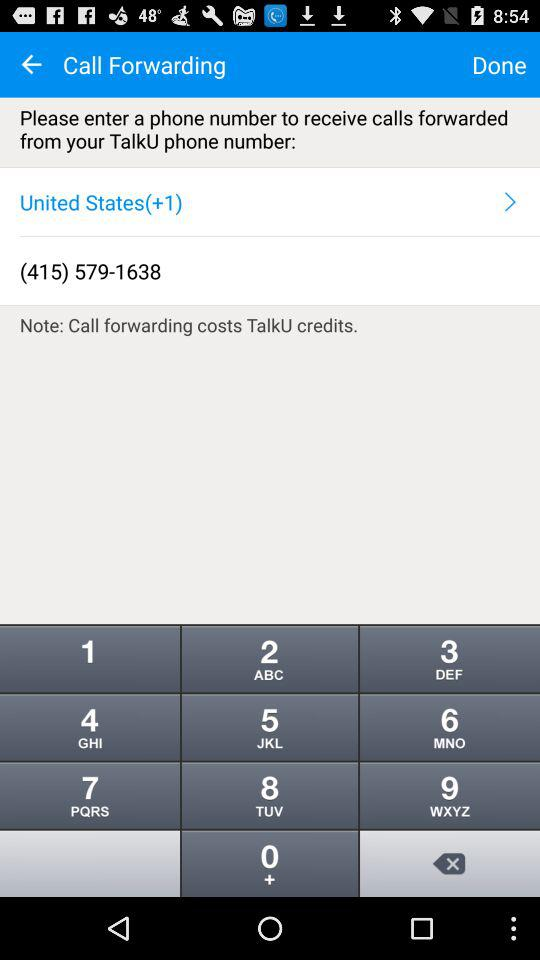What is the phone number? The phone number is (415) 579-1638. 